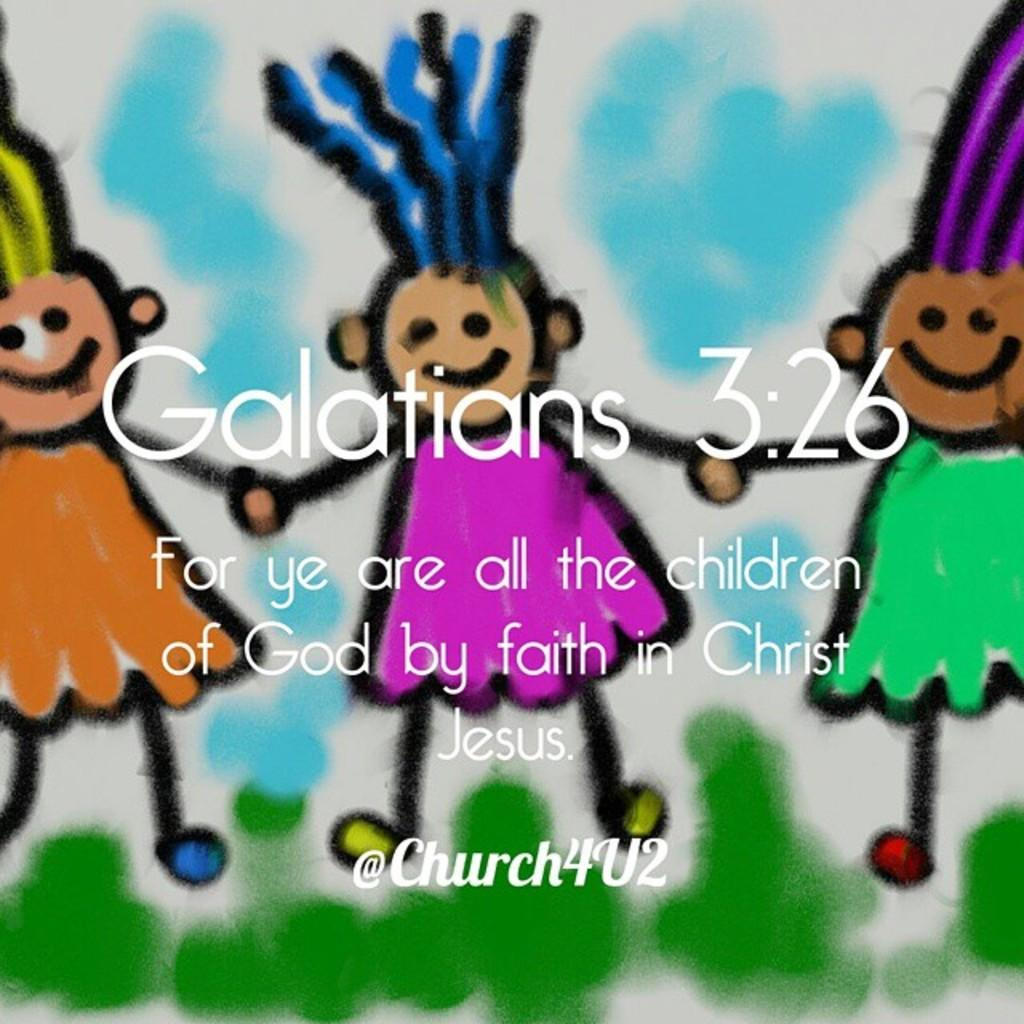What type of images are present in the picture? There are cartoon images in the picture. Is there any text present in the picture? Yes, there is text on the picture. How did the earthquake affect the cartoon images in the picture? There is no earthquake present in the image, so it cannot be determined how it would affect the cartoon images. 